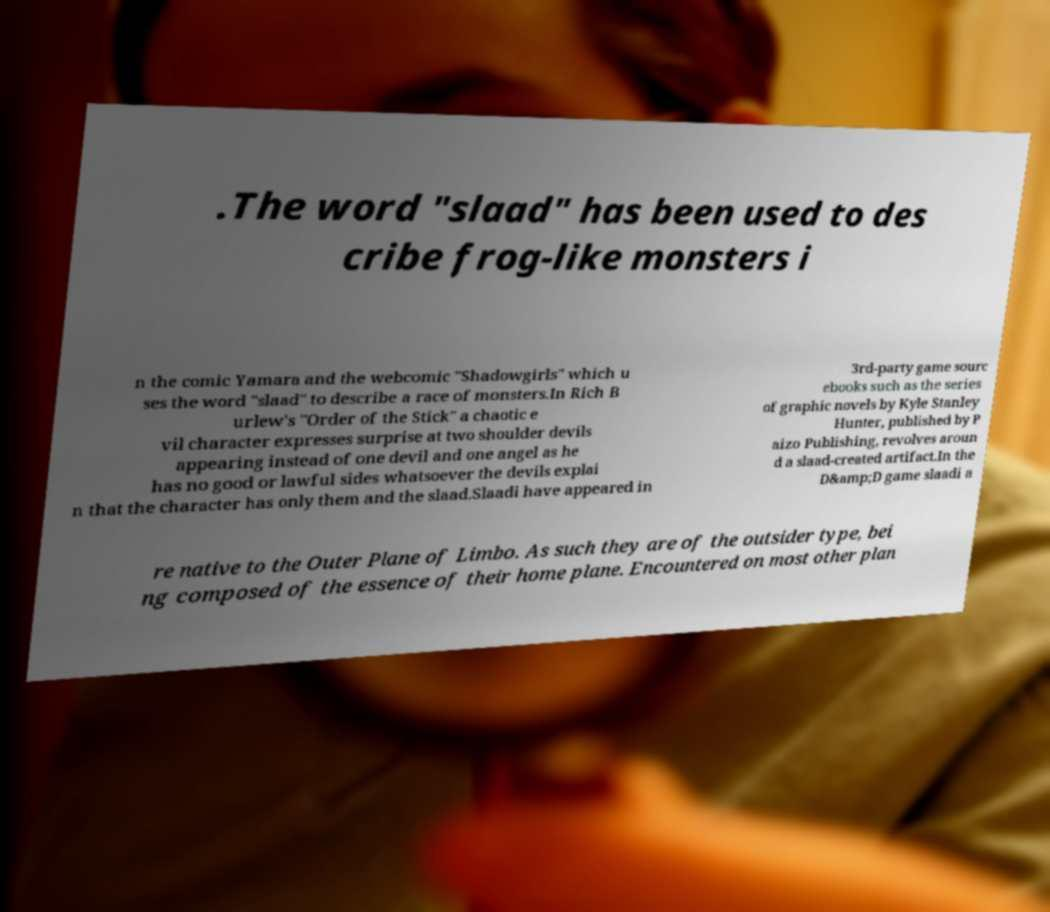Could you extract and type out the text from this image? .The word "slaad" has been used to des cribe frog-like monsters i n the comic Yamara and the webcomic "Shadowgirls" which u ses the word "slaad" to describe a race of monsters.In Rich B urlew's "Order of the Stick" a chaotic e vil character expresses surprise at two shoulder devils appearing instead of one devil and one angel as he has no good or lawful sides whatsoever the devils explai n that the character has only them and the slaad.Slaadi have appeared in 3rd-party game sourc ebooks such as the series of graphic novels by Kyle Stanley Hunter, published by P aizo Publishing, revolves aroun d a slaad-created artifact.In the D&amp;D game slaadi a re native to the Outer Plane of Limbo. As such they are of the outsider type, bei ng composed of the essence of their home plane. Encountered on most other plan 